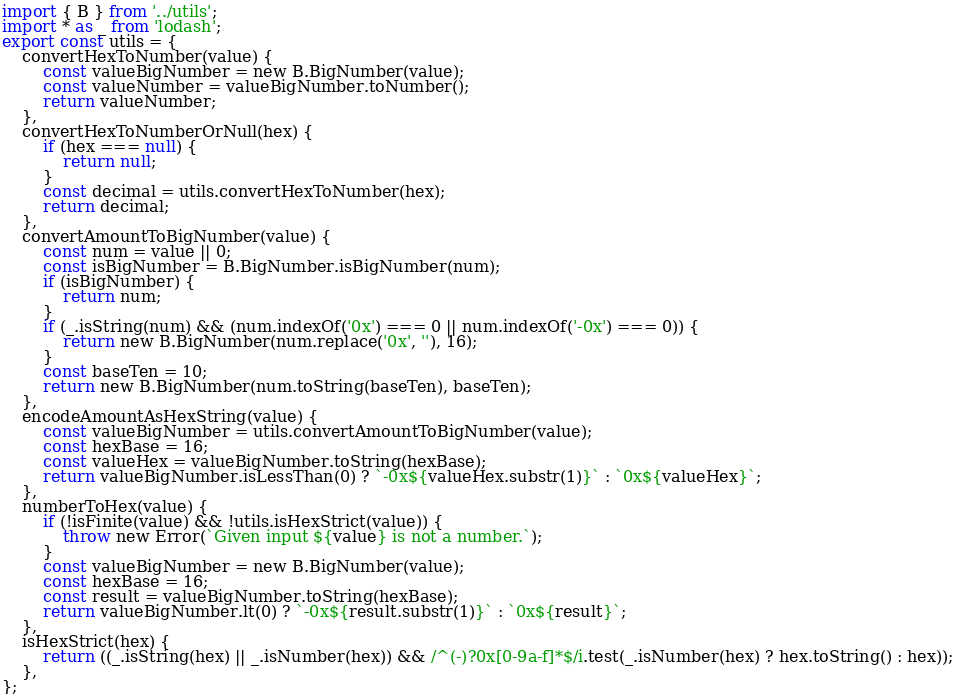Convert code to text. <code><loc_0><loc_0><loc_500><loc_500><_JavaScript_>import { B } from '../utils';
import * as _ from 'lodash';
export const utils = {
    convertHexToNumber(value) {
        const valueBigNumber = new B.BigNumber(value);
        const valueNumber = valueBigNumber.toNumber();
        return valueNumber;
    },
    convertHexToNumberOrNull(hex) {
        if (hex === null) {
            return null;
        }
        const decimal = utils.convertHexToNumber(hex);
        return decimal;
    },
    convertAmountToBigNumber(value) {
        const num = value || 0;
        const isBigNumber = B.BigNumber.isBigNumber(num);
        if (isBigNumber) {
            return num;
        }
        if (_.isString(num) && (num.indexOf('0x') === 0 || num.indexOf('-0x') === 0)) {
            return new B.BigNumber(num.replace('0x', ''), 16);
        }
        const baseTen = 10;
        return new B.BigNumber(num.toString(baseTen), baseTen);
    },
    encodeAmountAsHexString(value) {
        const valueBigNumber = utils.convertAmountToBigNumber(value);
        const hexBase = 16;
        const valueHex = valueBigNumber.toString(hexBase);
        return valueBigNumber.isLessThan(0) ? `-0x${valueHex.substr(1)}` : `0x${valueHex}`;
    },
    numberToHex(value) {
        if (!isFinite(value) && !utils.isHexStrict(value)) {
            throw new Error(`Given input ${value} is not a number.`);
        }
        const valueBigNumber = new B.BigNumber(value);
        const hexBase = 16;
        const result = valueBigNumber.toString(hexBase);
        return valueBigNumber.lt(0) ? `-0x${result.substr(1)}` : `0x${result}`;
    },
    isHexStrict(hex) {
        return ((_.isString(hex) || _.isNumber(hex)) && /^(-)?0x[0-9a-f]*$/i.test(_.isNumber(hex) ? hex.toString() : hex));
    },
};
</code> 